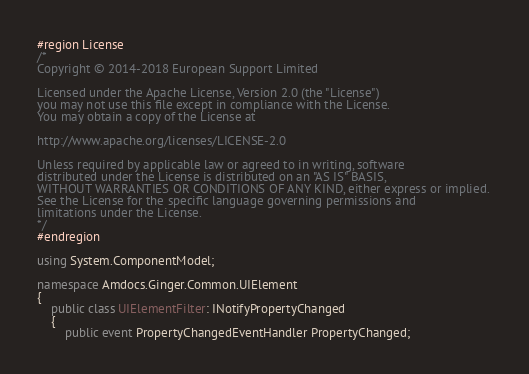Convert code to text. <code><loc_0><loc_0><loc_500><loc_500><_C#_>#region License
/*
Copyright © 2014-2018 European Support Limited

Licensed under the Apache License, Version 2.0 (the "License")
you may not use this file except in compliance with the License.
You may obtain a copy of the License at 

http://www.apache.org/licenses/LICENSE-2.0 

Unless required by applicable law or agreed to in writing, software
distributed under the License is distributed on an "AS IS" BASIS, 
WITHOUT WARRANTIES OR CONDITIONS OF ANY KIND, either express or implied. 
See the License for the specific language governing permissions and 
limitations under the License. 
*/
#endregion

using System.ComponentModel;

namespace Amdocs.Ginger.Common.UIElement
{
    public class UIElementFilter: INotifyPropertyChanged
    {
        public event PropertyChangedEventHandler PropertyChanged;</code> 